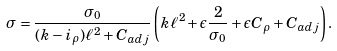<formula> <loc_0><loc_0><loc_500><loc_500>\sigma = \frac { \sigma _ { 0 } } { ( k - i _ { \rho } ) \ell ^ { 2 } + C _ { a d j } } \left ( k \ell ^ { 2 } + \epsilon \frac { 2 } { \sigma _ { 0 } } + \epsilon C _ { \rho } + C _ { a d j } \right ) .</formula> 